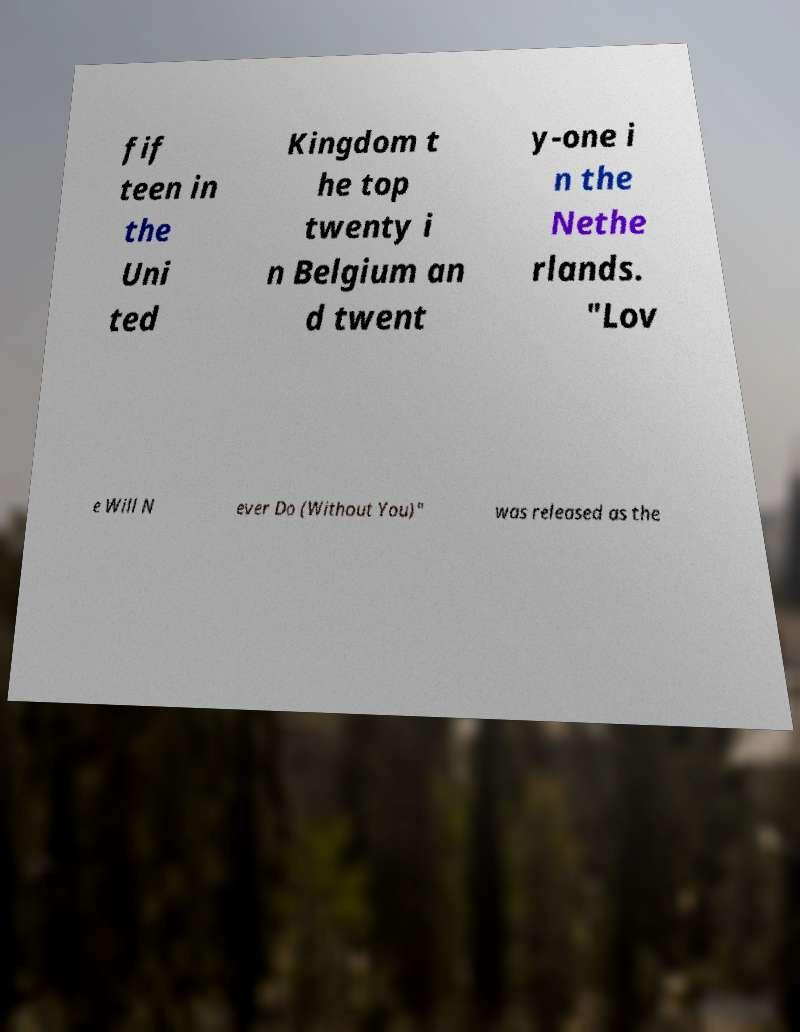Please identify and transcribe the text found in this image. fif teen in the Uni ted Kingdom t he top twenty i n Belgium an d twent y-one i n the Nethe rlands. "Lov e Will N ever Do (Without You)" was released as the 